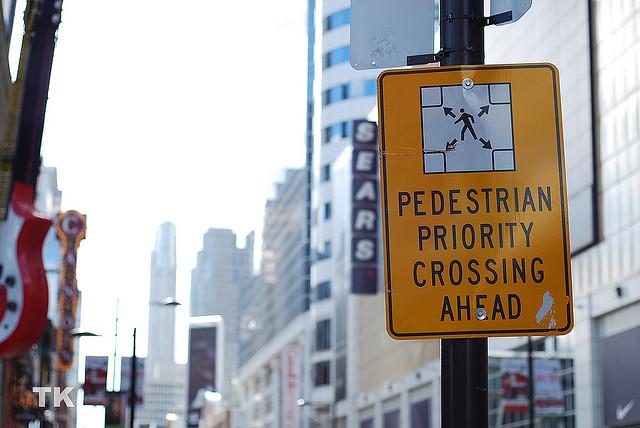What does the orange sign say?
Concise answer only. Pedestrian priority crossing ahead. What language is the sign written in?
Answer briefly. English. Would Ace Ventura say somebody before this?
Keep it brief. No. Are there any skyscrapers in the image?
Concise answer only. Yes. Is there special parking for the handicapped?
Write a very short answer. No. Do pedestrians have priority to cross?
Quick response, please. Yes. What is the most prominent color on the signs?
Give a very brief answer. Yellow. What is the yellow sign saying?
Give a very brief answer. Pedestrian priority crossing ahead. What color is this sign?
Concise answer only. Yellow. Are there any people?
Keep it brief. No. What is the color of the sign?
Quick response, please. Yellow. What department store is in the background?
Keep it brief. Sears. What color is the sign?
Quick response, please. Yellow. Are there trees?
Quick response, please. No. 